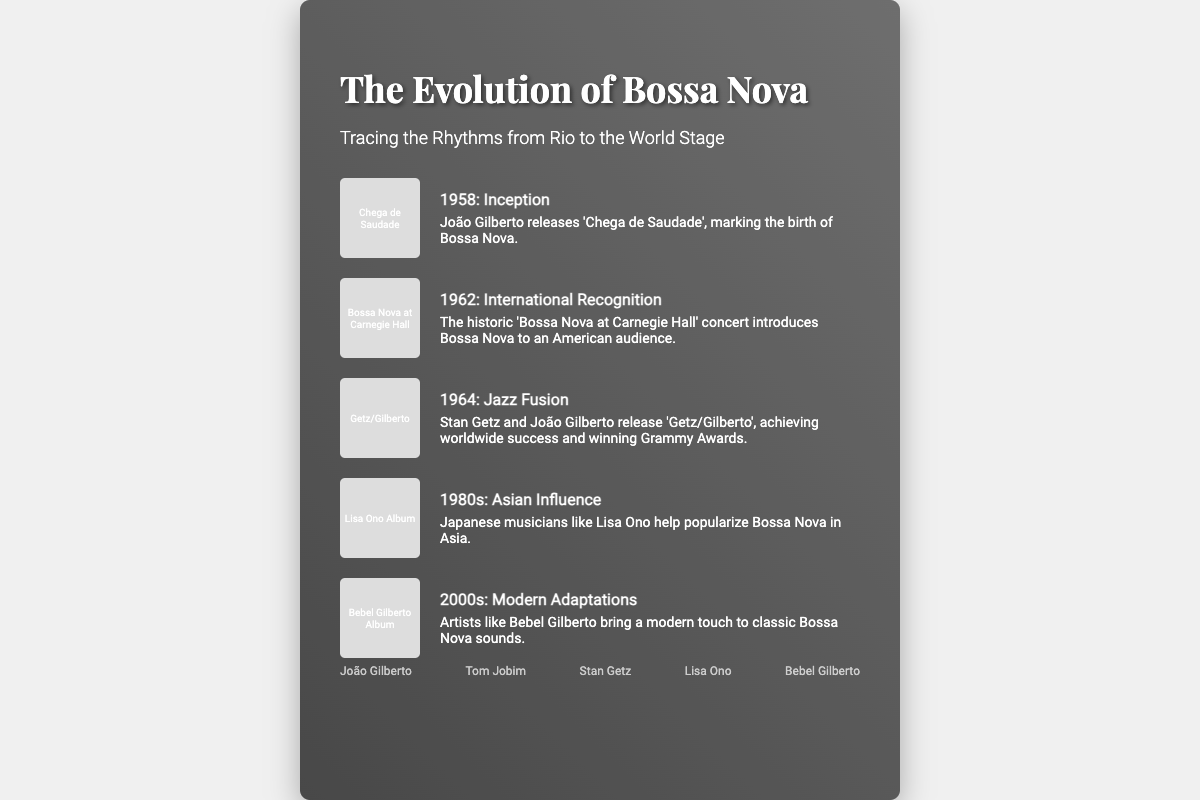What year did João Gilberto release 'Chega de Saudade'? The document states that 1958 marks the inception of Bossa Nova with João Gilberto's release of the album.
Answer: 1958 Which album introduced Bossa Nova to an American audience? The event mentions the concert 'Bossa Nova at Carnegie Hall' as the introduction of Bossa Nova to the American audience in 1962.
Answer: Bossa Nova at Carnegie Hall Who collaborated with João Gilberto on the album that achieved worldwide success in 1964? The document states that Stan Getz collaborated with João Gilberto on the album 'Getz/Gilberto'.
Answer: Stan Getz What decade saw Japanese musicians popularizing Bossa Nova in Asia? The timeline indicates that the 1980s featured the rise of Japanese musicians like Lisa Ono in promoting Bossa Nova.
Answer: 1980s Which artist is mentioned as bringing a modern touch to Bossa Nova in the 2000s? The document refers to Bebel Gilberto as an artist who modernized the classic Bossa Nova sounds in the 2000s.
Answer: Bebel Gilberto What type of document is this? The structure and content clearly indicate that this is a book cover about the evolution of Bossa Nova.
Answer: Book cover How many key musicians are listed at the bottom? The document highlights five key musicians in the list provided.
Answer: Five What is the significance of the world map in the background? The inclusion of the world map signifies the global influence of Bossa Nova as mentioned in the title.
Answer: Global influence 